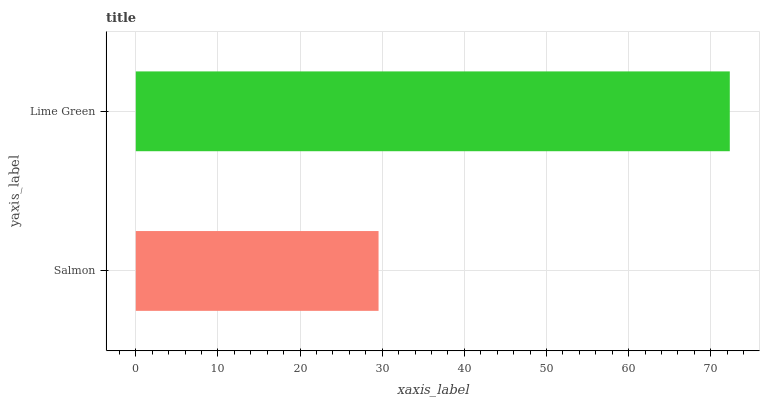Is Salmon the minimum?
Answer yes or no. Yes. Is Lime Green the maximum?
Answer yes or no. Yes. Is Lime Green the minimum?
Answer yes or no. No. Is Lime Green greater than Salmon?
Answer yes or no. Yes. Is Salmon less than Lime Green?
Answer yes or no. Yes. Is Salmon greater than Lime Green?
Answer yes or no. No. Is Lime Green less than Salmon?
Answer yes or no. No. Is Lime Green the high median?
Answer yes or no. Yes. Is Salmon the low median?
Answer yes or no. Yes. Is Salmon the high median?
Answer yes or no. No. Is Lime Green the low median?
Answer yes or no. No. 